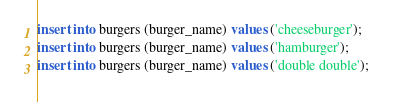Convert code to text. <code><loc_0><loc_0><loc_500><loc_500><_SQL_>insert into burgers (burger_name) values ('cheeseburger');
insert into burgers (burger_name) values ('hamburger');
insert into burgers (burger_name) values ('double double');</code> 